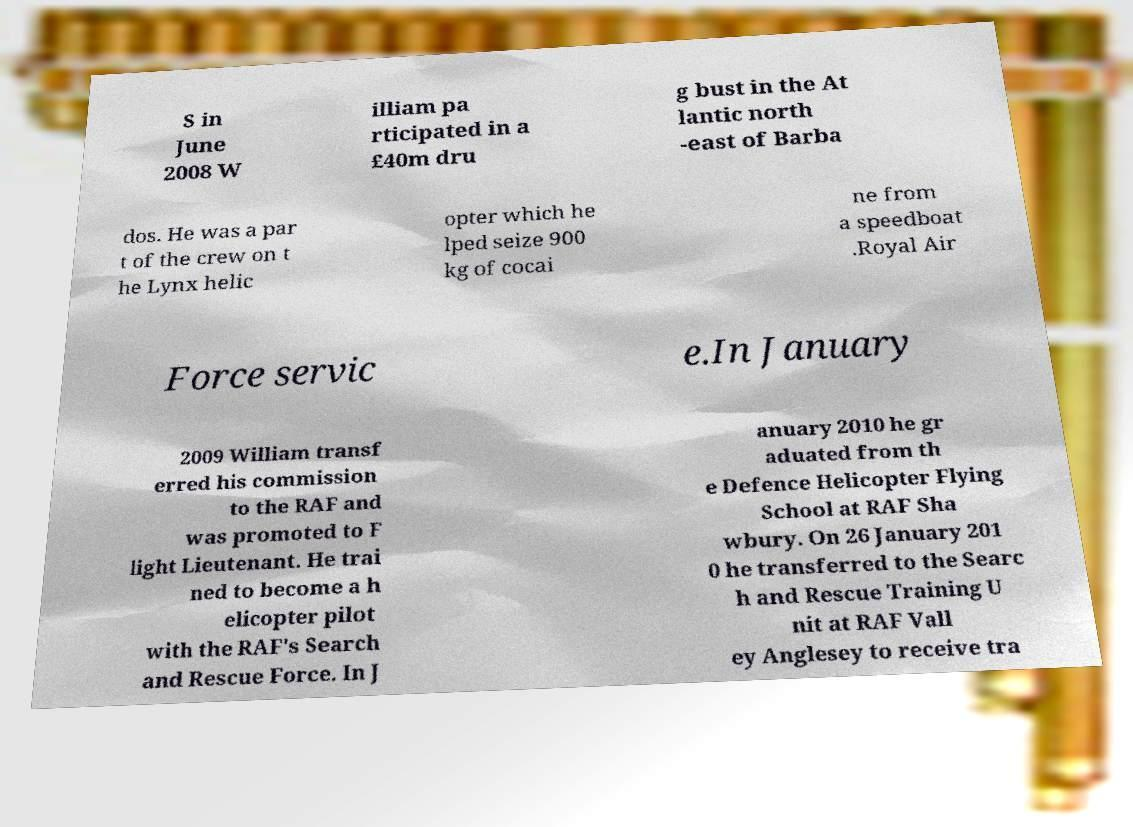Can you read and provide the text displayed in the image?This photo seems to have some interesting text. Can you extract and type it out for me? S in June 2008 W illiam pa rticipated in a £40m dru g bust in the At lantic north -east of Barba dos. He was a par t of the crew on t he Lynx helic opter which he lped seize 900 kg of cocai ne from a speedboat .Royal Air Force servic e.In January 2009 William transf erred his commission to the RAF and was promoted to F light Lieutenant. He trai ned to become a h elicopter pilot with the RAF's Search and Rescue Force. In J anuary 2010 he gr aduated from th e Defence Helicopter Flying School at RAF Sha wbury. On 26 January 201 0 he transferred to the Searc h and Rescue Training U nit at RAF Vall ey Anglesey to receive tra 